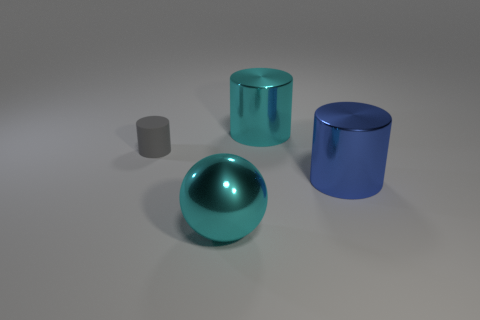Subtract all large blue cylinders. How many cylinders are left? 2 Add 3 cyan balls. How many objects exist? 7 Subtract 1 cylinders. How many cylinders are left? 2 Subtract all cylinders. How many objects are left? 1 Add 2 big gray rubber objects. How many big gray rubber objects exist? 2 Subtract 0 brown cylinders. How many objects are left? 4 Subtract all brown cylinders. Subtract all gray spheres. How many cylinders are left? 3 Subtract all tiny cyan rubber cylinders. Subtract all gray rubber cylinders. How many objects are left? 3 Add 1 spheres. How many spheres are left? 2 